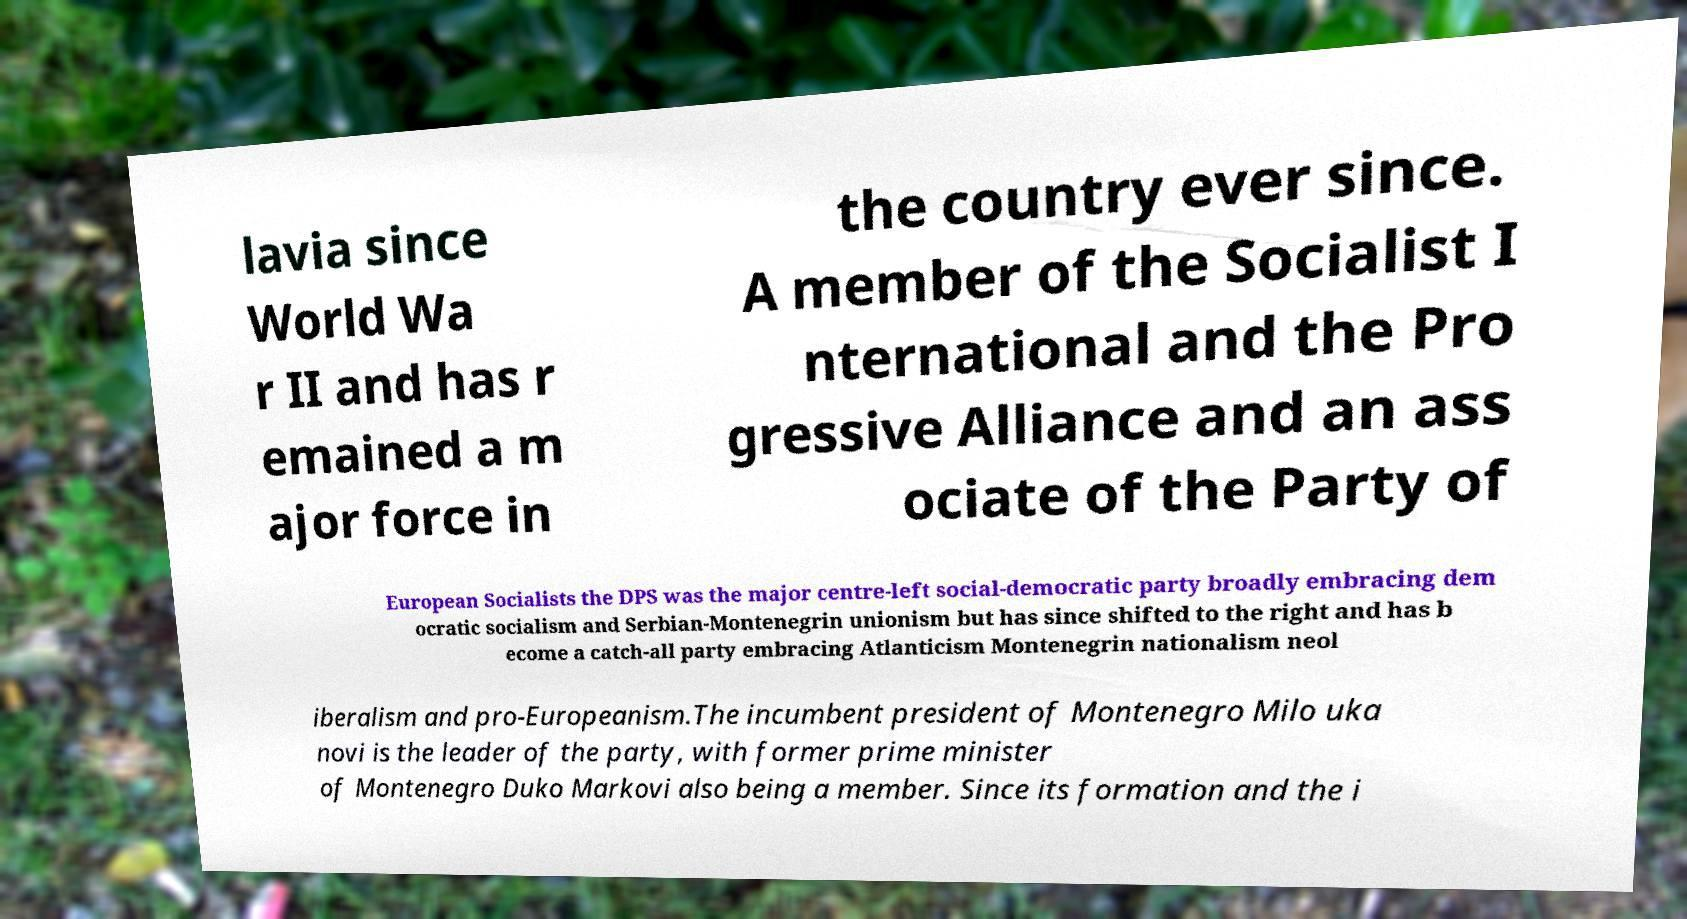There's text embedded in this image that I need extracted. Can you transcribe it verbatim? lavia since World Wa r II and has r emained a m ajor force in the country ever since. A member of the Socialist I nternational and the Pro gressive Alliance and an ass ociate of the Party of European Socialists the DPS was the major centre-left social-democratic party broadly embracing dem ocratic socialism and Serbian-Montenegrin unionism but has since shifted to the right and has b ecome a catch-all party embracing Atlanticism Montenegrin nationalism neol iberalism and pro-Europeanism.The incumbent president of Montenegro Milo uka novi is the leader of the party, with former prime minister of Montenegro Duko Markovi also being a member. Since its formation and the i 